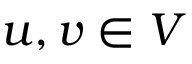<formula> <loc_0><loc_0><loc_500><loc_500>u , v \in V</formula> 